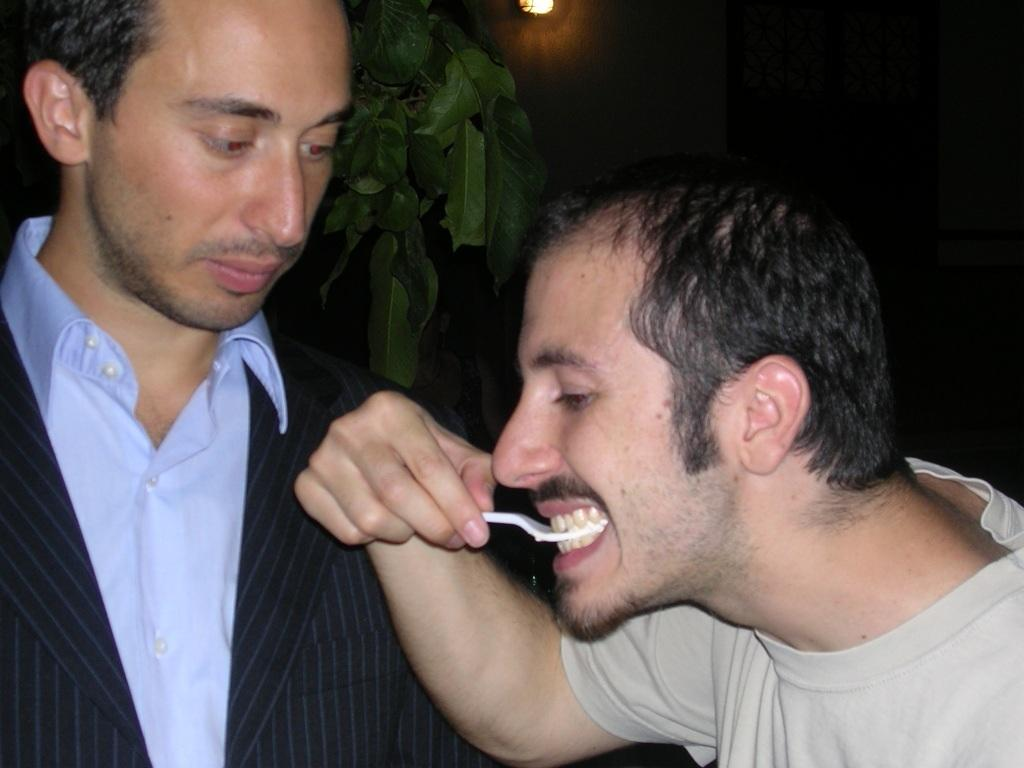What is happening with the people in the image? There are people standing in the image. Can you describe the man's action in the image? A man is holding a spoon in his mouth. What type of vegetation can be seen in the image? There is a plant visible in the image. What type of wave can be seen in the background of the image? There is no wave visible in the image; it only features people, a man holding a spoon, and a plant. 